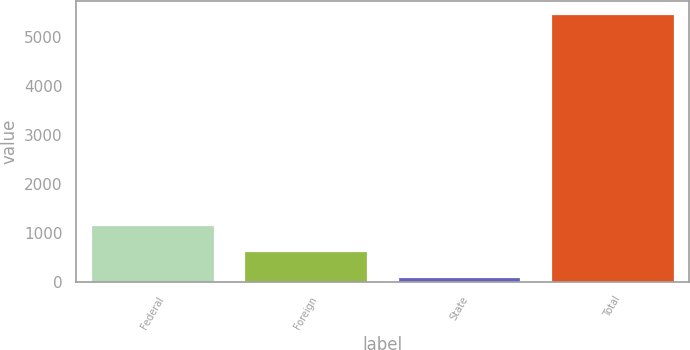Convert chart to OTSL. <chart><loc_0><loc_0><loc_500><loc_500><bar_chart><fcel>Federal<fcel>Foreign<fcel>State<fcel>Total<nl><fcel>1165.8<fcel>627.9<fcel>90<fcel>5469<nl></chart> 